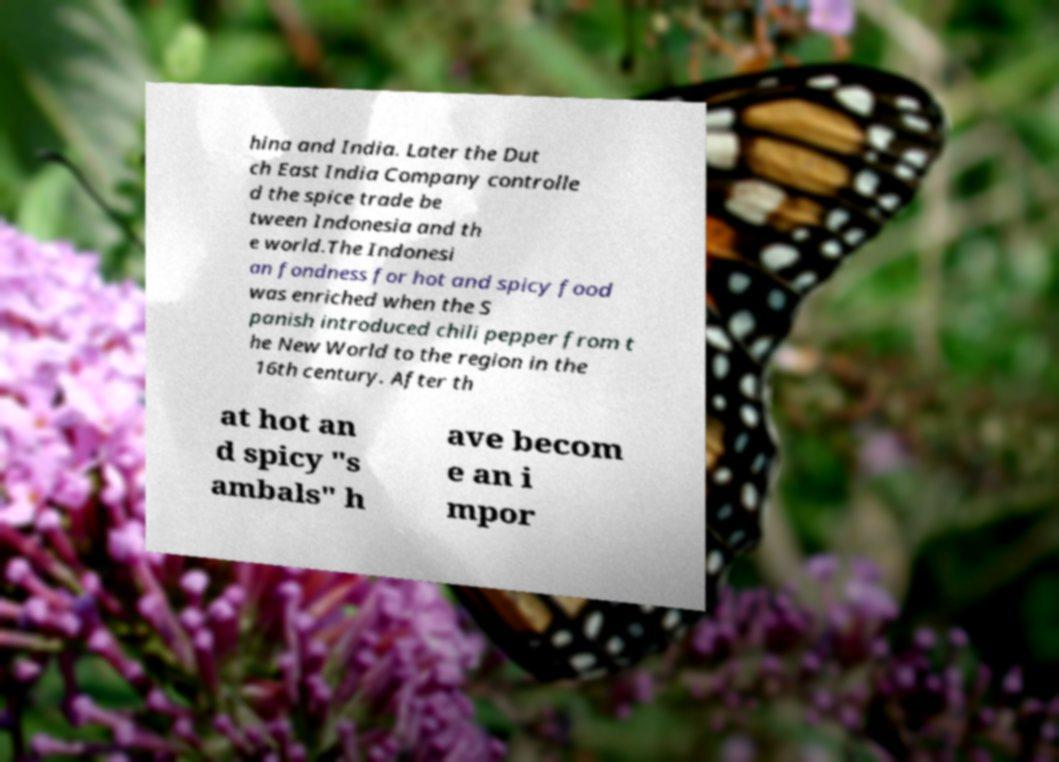Can you accurately transcribe the text from the provided image for me? hina and India. Later the Dut ch East India Company controlle d the spice trade be tween Indonesia and th e world.The Indonesi an fondness for hot and spicy food was enriched when the S panish introduced chili pepper from t he New World to the region in the 16th century. After th at hot an d spicy "s ambals" h ave becom e an i mpor 